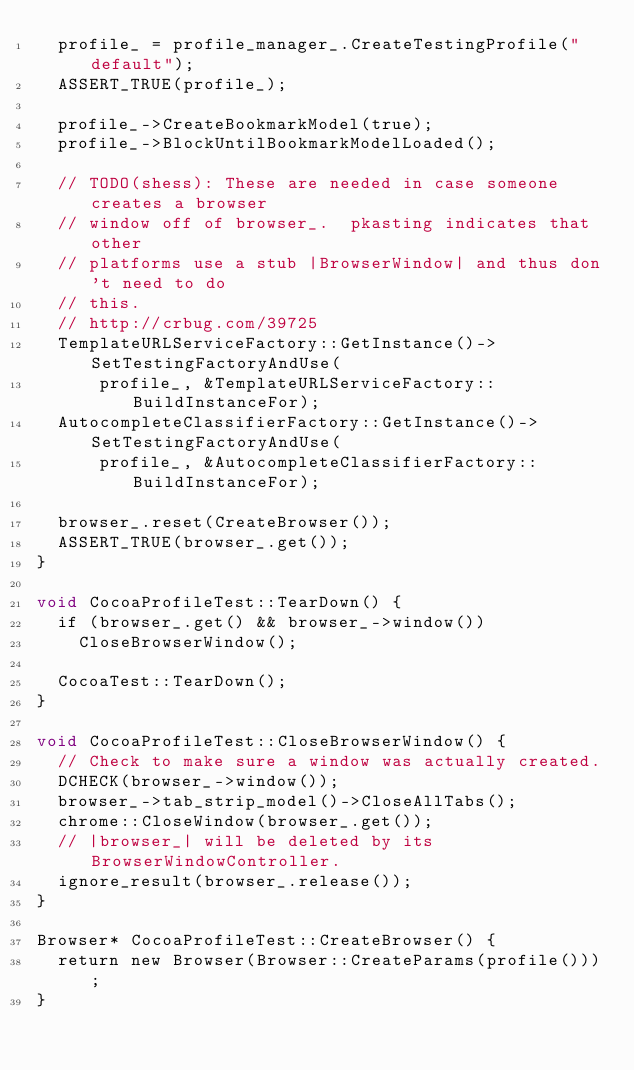<code> <loc_0><loc_0><loc_500><loc_500><_ObjectiveC_>  profile_ = profile_manager_.CreateTestingProfile("default");
  ASSERT_TRUE(profile_);

  profile_->CreateBookmarkModel(true);
  profile_->BlockUntilBookmarkModelLoaded();

  // TODO(shess): These are needed in case someone creates a browser
  // window off of browser_.  pkasting indicates that other
  // platforms use a stub |BrowserWindow| and thus don't need to do
  // this.
  // http://crbug.com/39725
  TemplateURLServiceFactory::GetInstance()->SetTestingFactoryAndUse(
      profile_, &TemplateURLServiceFactory::BuildInstanceFor);
  AutocompleteClassifierFactory::GetInstance()->SetTestingFactoryAndUse(
      profile_, &AutocompleteClassifierFactory::BuildInstanceFor);

  browser_.reset(CreateBrowser());
  ASSERT_TRUE(browser_.get());
}

void CocoaProfileTest::TearDown() {
  if (browser_.get() && browser_->window())
    CloseBrowserWindow();

  CocoaTest::TearDown();
}

void CocoaProfileTest::CloseBrowserWindow() {
  // Check to make sure a window was actually created.
  DCHECK(browser_->window());
  browser_->tab_strip_model()->CloseAllTabs();
  chrome::CloseWindow(browser_.get());
  // |browser_| will be deleted by its BrowserWindowController.
  ignore_result(browser_.release());
}

Browser* CocoaProfileTest::CreateBrowser() {
  return new Browser(Browser::CreateParams(profile()));
}
</code> 